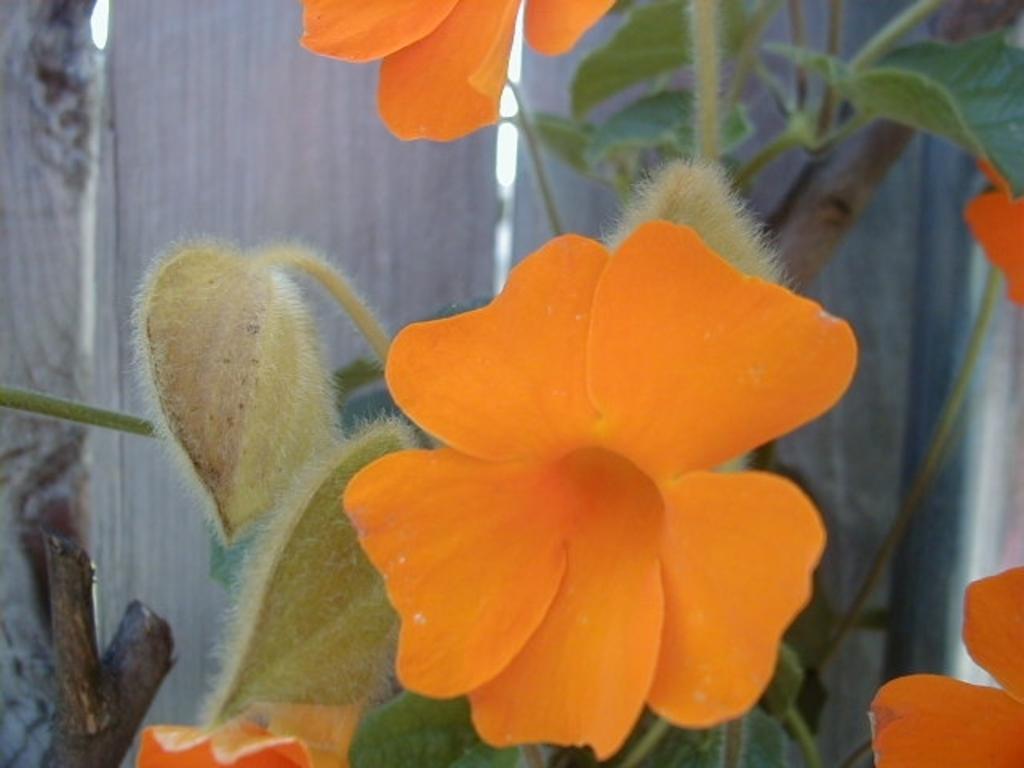Describe this image in one or two sentences. In this image there are flowers and there is a plant. In the background there is a wooden wall. 